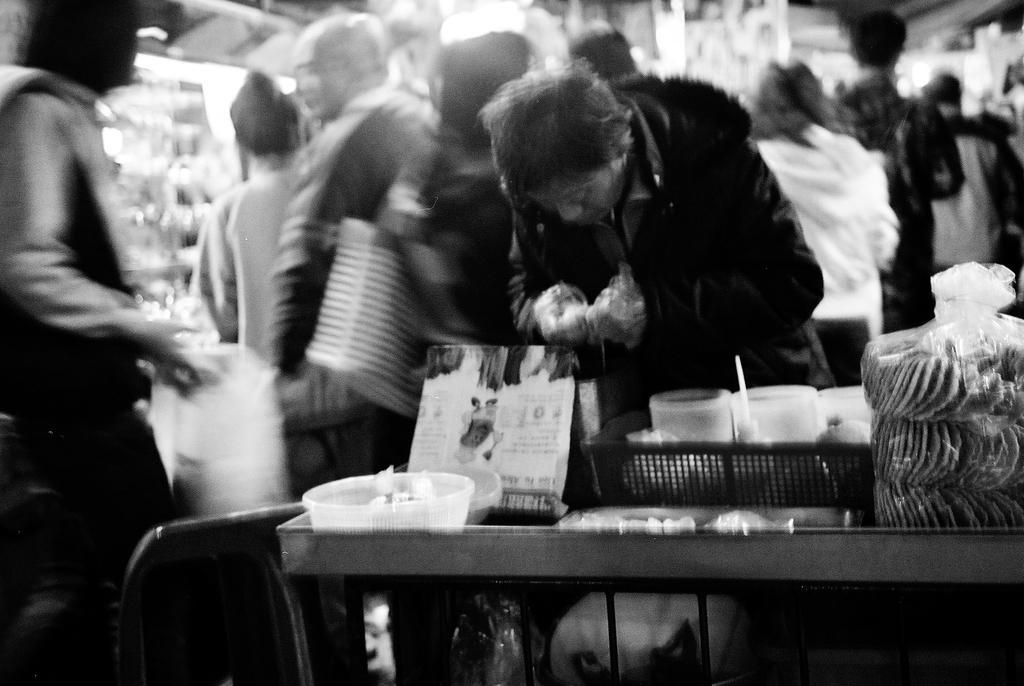In one or two sentences, can you explain what this image depicts? In the picture we can see a man standing near the table and checking the items, on the table we can see a basket with cups, a stand paper, a bowls, and some cover bag, just beside to him there is another person standing and behind there are some people standing. 